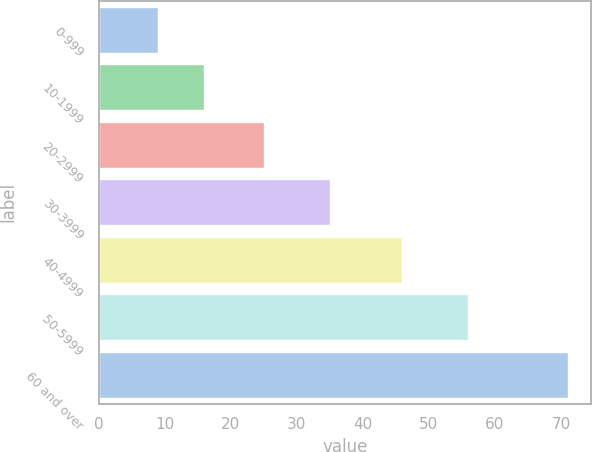Convert chart to OTSL. <chart><loc_0><loc_0><loc_500><loc_500><bar_chart><fcel>0-999<fcel>10-1999<fcel>20-2999<fcel>30-3999<fcel>40-4999<fcel>50-5999<fcel>60 and over<nl><fcel>9<fcel>16<fcel>25<fcel>35<fcel>46<fcel>56<fcel>71<nl></chart> 